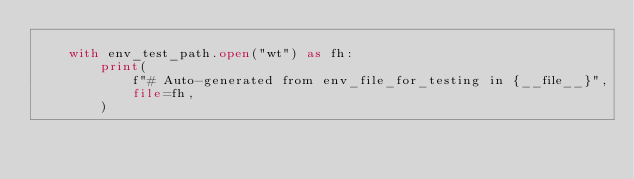Convert code to text. <code><loc_0><loc_0><loc_500><loc_500><_Python_>
    with env_test_path.open("wt") as fh:
        print(
            f"# Auto-generated from env_file_for_testing in {__file__}",
            file=fh,
        )</code> 